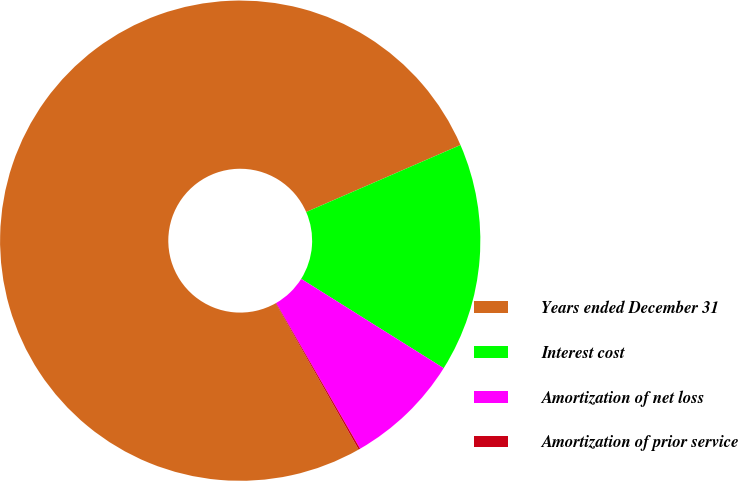Convert chart. <chart><loc_0><loc_0><loc_500><loc_500><pie_chart><fcel>Years ended December 31<fcel>Interest cost<fcel>Amortization of net loss<fcel>Amortization of prior service<nl><fcel>76.68%<fcel>15.43%<fcel>7.77%<fcel>0.11%<nl></chart> 